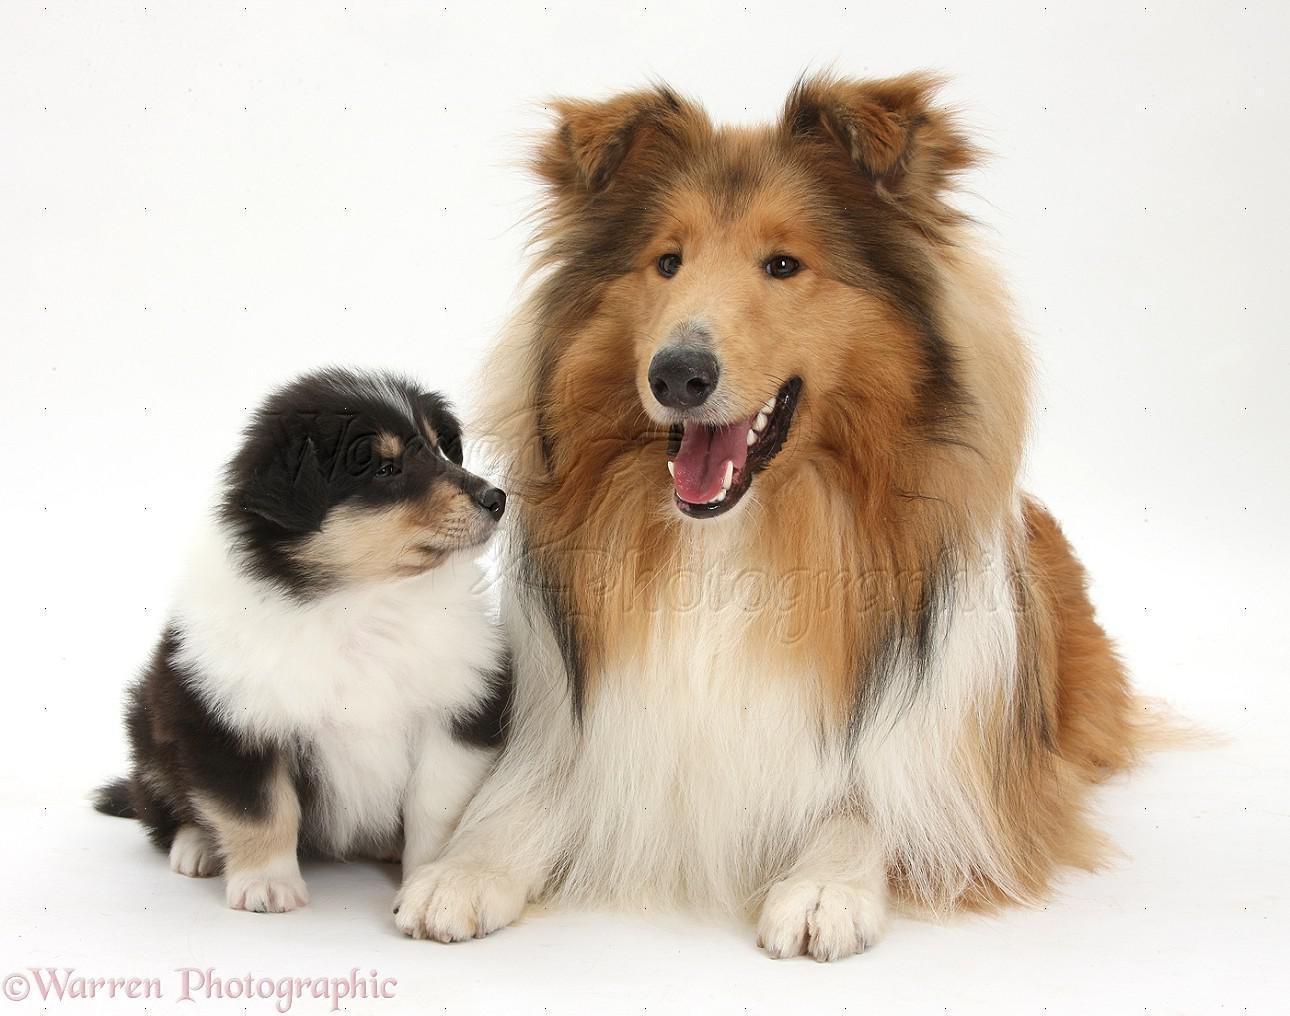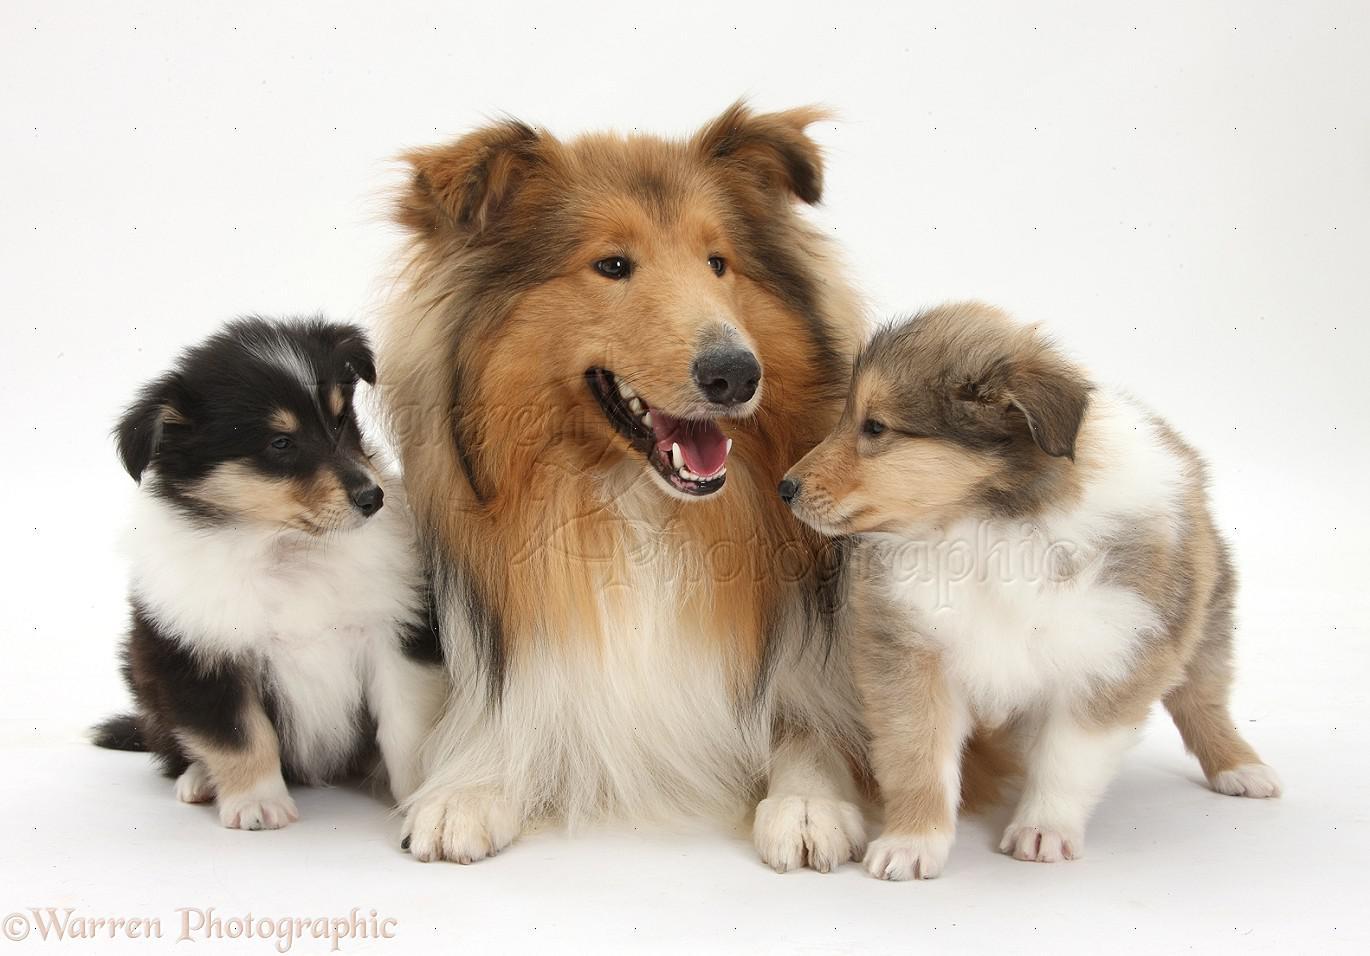The first image is the image on the left, the second image is the image on the right. Analyze the images presented: Is the assertion "There are at most 4 collies in the pair of images." valid? Answer yes or no. No. The first image is the image on the left, the second image is the image on the right. Evaluate the accuracy of this statement regarding the images: "The right image contains exactly three dogs.". Is it true? Answer yes or no. Yes. 